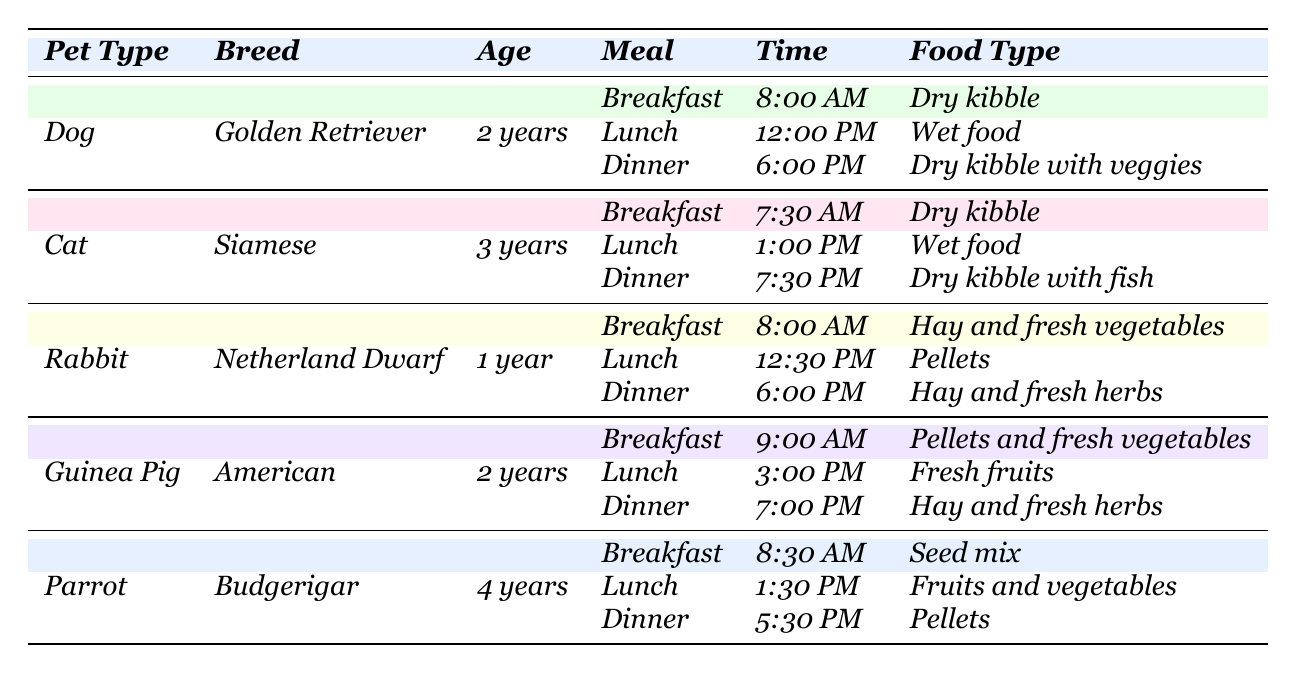What is the dinner food type for the Golden Retriever? The table shows that for the Golden Retriever's dinner, the food type is "Dry kibble with veggies," which is listed under the dinner meal for that pet.
Answer: Dry kibble with veggies How many meals does the Siamese cat have in a day? According to the table, the Siamese cat has three meals in a day: breakfast, lunch, and dinner.
Answer: Three meals Is the lunch food type for the rabbit pellets? The table indicates that the lunch food type for the rabbit is "Pellets," so the answer is yes.
Answer: Yes What time does the guinea pig have its breakfast? The table specifies that the guinea pig's breakfast is at 9:00 AM.
Answer: 9:00 AM How does the feeding schedule differ between the parrot and the cat? The table shows the parrot has its meals at 8:30 AM, 1:30 PM, and 5:30 PM, while the cat's meals are at 7:30 AM, 1:00 PM, and 7:30 PM. This indicates that the order and timing of meals for these two pets are different.
Answer: Different times and order Does the rabbit have the same food type for all three meals? The table details that the rabbit has different food types for its three meals: hay and fresh vegetables for breakfast, pellets for lunch, and hay and fresh herbs for dinner. Therefore, the answer is no.
Answer: No What is the average age of the pets listed in the table? By summing up the ages of the pets: 2 (Dog) + 3 (Cat) + 1 (Rabbit) + 2 (Guinea Pig) + 4 (Parrot) gives 12 years. Since there are 5 pets, the average age is 12/5 = 2.4 years.
Answer: 2.4 years Which pet has its last meal the latest in the evening? By examining the table, the Siamese cat has its last meal at 7:30 PM, which is later than the other pets' last meals.
Answer: Siamese cat Are there any pets that have the same food type for breakfast and dinner? The table tells us that the Golden Retriever has "Dry kibble" for breakfast and "Dry kibble with veggies" for dinner, the Siamese has "Dry kibble" for breakfast and "Dry kibble with fish" for dinner, the rabbit has different food types, and the guinea pig has "Pellets and fresh vegetables" for breakfast and "Hay and fresh herbs" for dinner. The parrot has "Seed mix" for breakfast and "Pellets" for dinner. Thus, the answer is no because there are no matches.
Answer: No What type of food does the budgerigar receive for lunch? The table specifies that the budgerigar's lunch food type is "Fruits and vegetables," which refers directly to the listed meal for the parrot.
Answer: Fruits and vegetables 